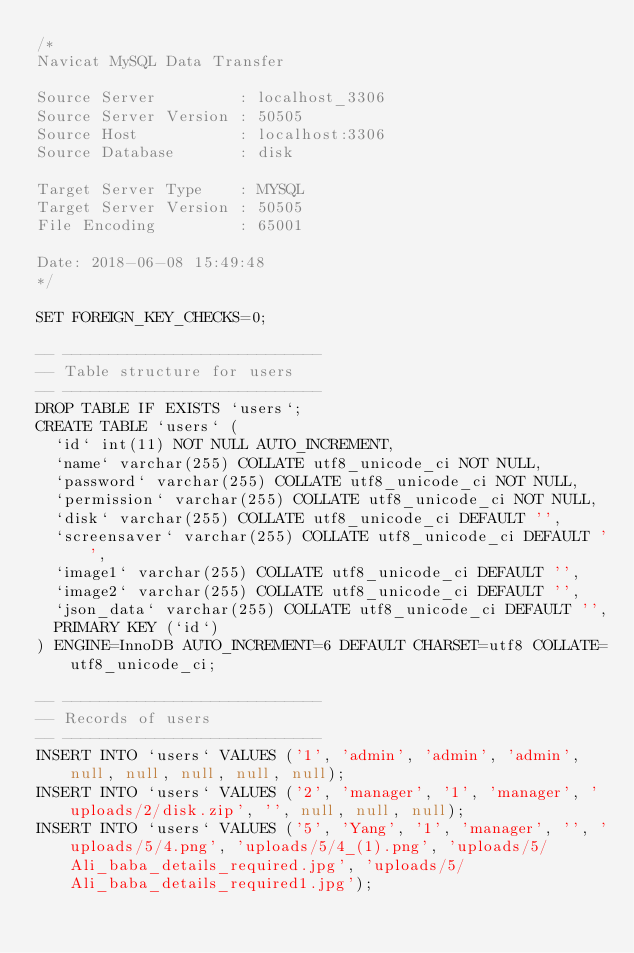Convert code to text. <code><loc_0><loc_0><loc_500><loc_500><_SQL_>/*
Navicat MySQL Data Transfer

Source Server         : localhost_3306
Source Server Version : 50505
Source Host           : localhost:3306
Source Database       : disk

Target Server Type    : MYSQL
Target Server Version : 50505
File Encoding         : 65001

Date: 2018-06-08 15:49:48
*/

SET FOREIGN_KEY_CHECKS=0;

-- ----------------------------
-- Table structure for users
-- ----------------------------
DROP TABLE IF EXISTS `users`;
CREATE TABLE `users` (
  `id` int(11) NOT NULL AUTO_INCREMENT,
  `name` varchar(255) COLLATE utf8_unicode_ci NOT NULL,
  `password` varchar(255) COLLATE utf8_unicode_ci NOT NULL,
  `permission` varchar(255) COLLATE utf8_unicode_ci NOT NULL,
  `disk` varchar(255) COLLATE utf8_unicode_ci DEFAULT '',
  `screensaver` varchar(255) COLLATE utf8_unicode_ci DEFAULT '',
  `image1` varchar(255) COLLATE utf8_unicode_ci DEFAULT '',
  `image2` varchar(255) COLLATE utf8_unicode_ci DEFAULT '',
  `json_data` varchar(255) COLLATE utf8_unicode_ci DEFAULT '',
  PRIMARY KEY (`id`)
) ENGINE=InnoDB AUTO_INCREMENT=6 DEFAULT CHARSET=utf8 COLLATE=utf8_unicode_ci;

-- ----------------------------
-- Records of users
-- ----------------------------
INSERT INTO `users` VALUES ('1', 'admin', 'admin', 'admin', null, null, null, null, null);
INSERT INTO `users` VALUES ('2', 'manager', '1', 'manager', 'uploads/2/disk.zip', '', null, null, null);
INSERT INTO `users` VALUES ('5', 'Yang', '1', 'manager', '', 'uploads/5/4.png', 'uploads/5/4_(1).png', 'uploads/5/Ali_baba_details_required.jpg', 'uploads/5/Ali_baba_details_required1.jpg');
</code> 